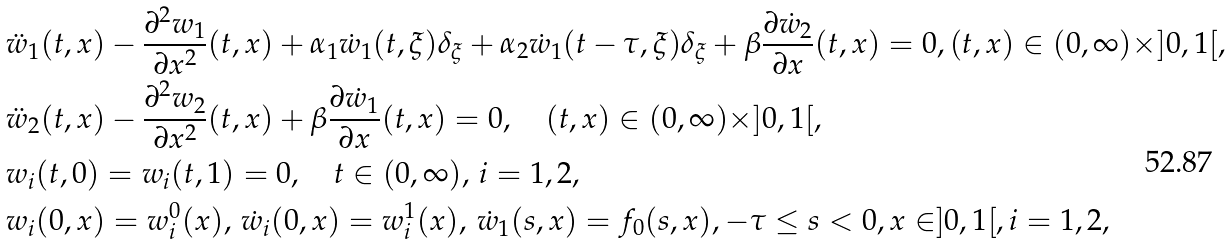<formula> <loc_0><loc_0><loc_500><loc_500>& \ddot { w } _ { 1 } ( t , x ) - \frac { \partial ^ { 2 } w _ { 1 } } { \partial x ^ { 2 } } ( t , x ) + \alpha _ { 1 } \dot { w } _ { 1 } ( t , \xi ) \delta _ { \xi } + \alpha _ { 2 } \dot { w } _ { 1 } ( t - \tau , \xi ) \delta _ { \xi } + \beta \frac { \partial \dot { w } _ { 2 } } { \partial x } ( t , x ) = 0 , ( t , x ) \in ( 0 , \infty ) \times ] 0 , 1 [ , \\ & \ddot { w } _ { 2 } ( t , x ) - \frac { \partial ^ { 2 } w _ { 2 } } { \partial x ^ { 2 } } ( t , x ) + \beta \frac { \partial \dot { w } _ { 1 } } { \partial x } ( t , x ) = 0 , \quad ( t , x ) \in ( 0 , \infty ) \times ] 0 , 1 [ , \\ & w _ { i } ( t , 0 ) = w _ { i } ( t , 1 ) = 0 , \quad t \in ( 0 , \infty ) , \, i = 1 , 2 , \\ & w _ { i } ( 0 , x ) = w _ { i } ^ { 0 } ( x ) , \, \dot { w } _ { i } ( 0 , x ) = w _ { i } ^ { 1 } ( x ) , \, \dot { w } _ { 1 } ( s , x ) = f _ { 0 } ( s , x ) , - \tau \leq s < 0 , x \in ] 0 , 1 [ , i = 1 , 2 ,</formula> 